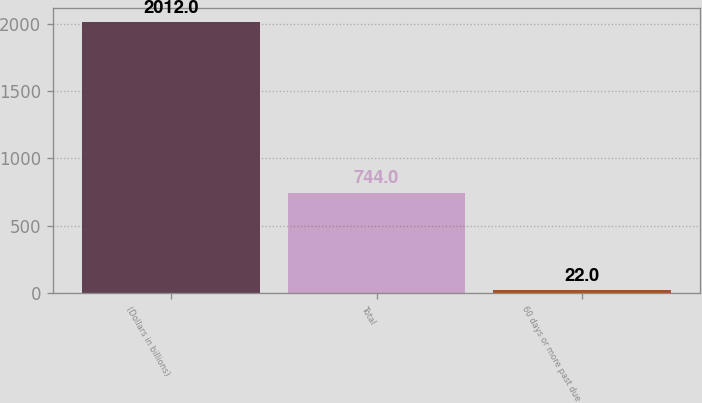Convert chart. <chart><loc_0><loc_0><loc_500><loc_500><bar_chart><fcel>(Dollars in billions)<fcel>Total<fcel>60 days or more past due<nl><fcel>2012<fcel>744<fcel>22<nl></chart> 